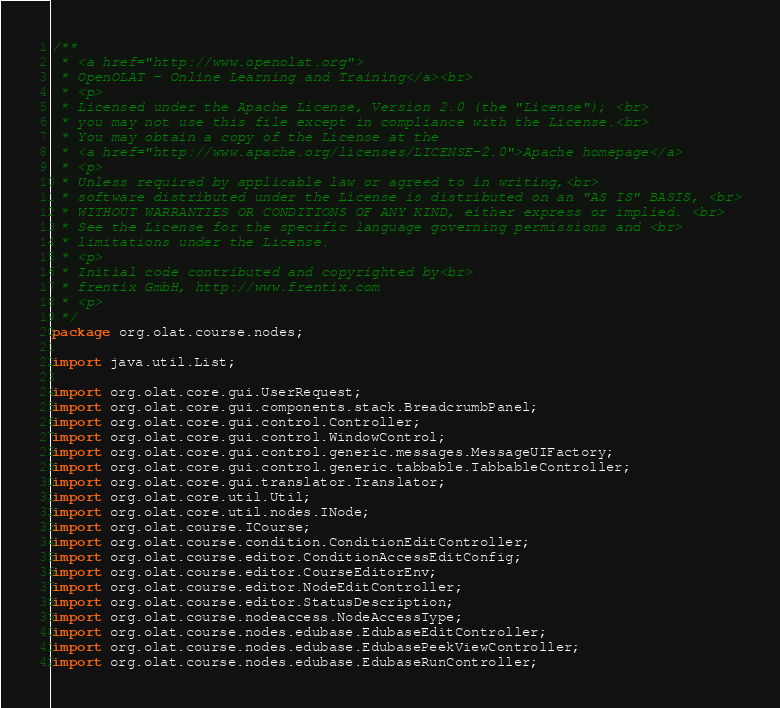<code> <loc_0><loc_0><loc_500><loc_500><_Java_>/**
 * <a href="http://www.openolat.org">
 * OpenOLAT - Online Learning and Training</a><br>
 * <p>
 * Licensed under the Apache License, Version 2.0 (the "License"); <br>
 * you may not use this file except in compliance with the License.<br>
 * You may obtain a copy of the License at the
 * <a href="http://www.apache.org/licenses/LICENSE-2.0">Apache homepage</a>
 * <p>
 * Unless required by applicable law or agreed to in writing,<br>
 * software distributed under the License is distributed on an "AS IS" BASIS, <br>
 * WITHOUT WARRANTIES OR CONDITIONS OF ANY KIND, either express or implied. <br>
 * See the License for the specific language governing permissions and <br>
 * limitations under the License.
 * <p>
 * Initial code contributed and copyrighted by<br>
 * frentix GmbH, http://www.frentix.com
 * <p>
 */
package org.olat.course.nodes;

import java.util.List;

import org.olat.core.gui.UserRequest;
import org.olat.core.gui.components.stack.BreadcrumbPanel;
import org.olat.core.gui.control.Controller;
import org.olat.core.gui.control.WindowControl;
import org.olat.core.gui.control.generic.messages.MessageUIFactory;
import org.olat.core.gui.control.generic.tabbable.TabbableController;
import org.olat.core.gui.translator.Translator;
import org.olat.core.util.Util;
import org.olat.core.util.nodes.INode;
import org.olat.course.ICourse;
import org.olat.course.condition.ConditionEditController;
import org.olat.course.editor.ConditionAccessEditConfig;
import org.olat.course.editor.CourseEditorEnv;
import org.olat.course.editor.NodeEditController;
import org.olat.course.editor.StatusDescription;
import org.olat.course.nodeaccess.NodeAccessType;
import org.olat.course.nodes.edubase.EdubaseEditController;
import org.olat.course.nodes.edubase.EdubasePeekViewController;
import org.olat.course.nodes.edubase.EdubaseRunController;</code> 